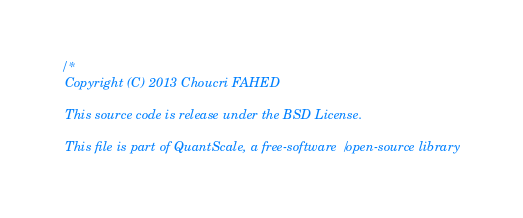<code> <loc_0><loc_0><loc_500><loc_500><_Scala_>/*
 Copyright (C) 2013 Choucri FAHED

 This source code is release under the BSD License.

 This file is part of QuantScale, a free-software/open-source library</code> 